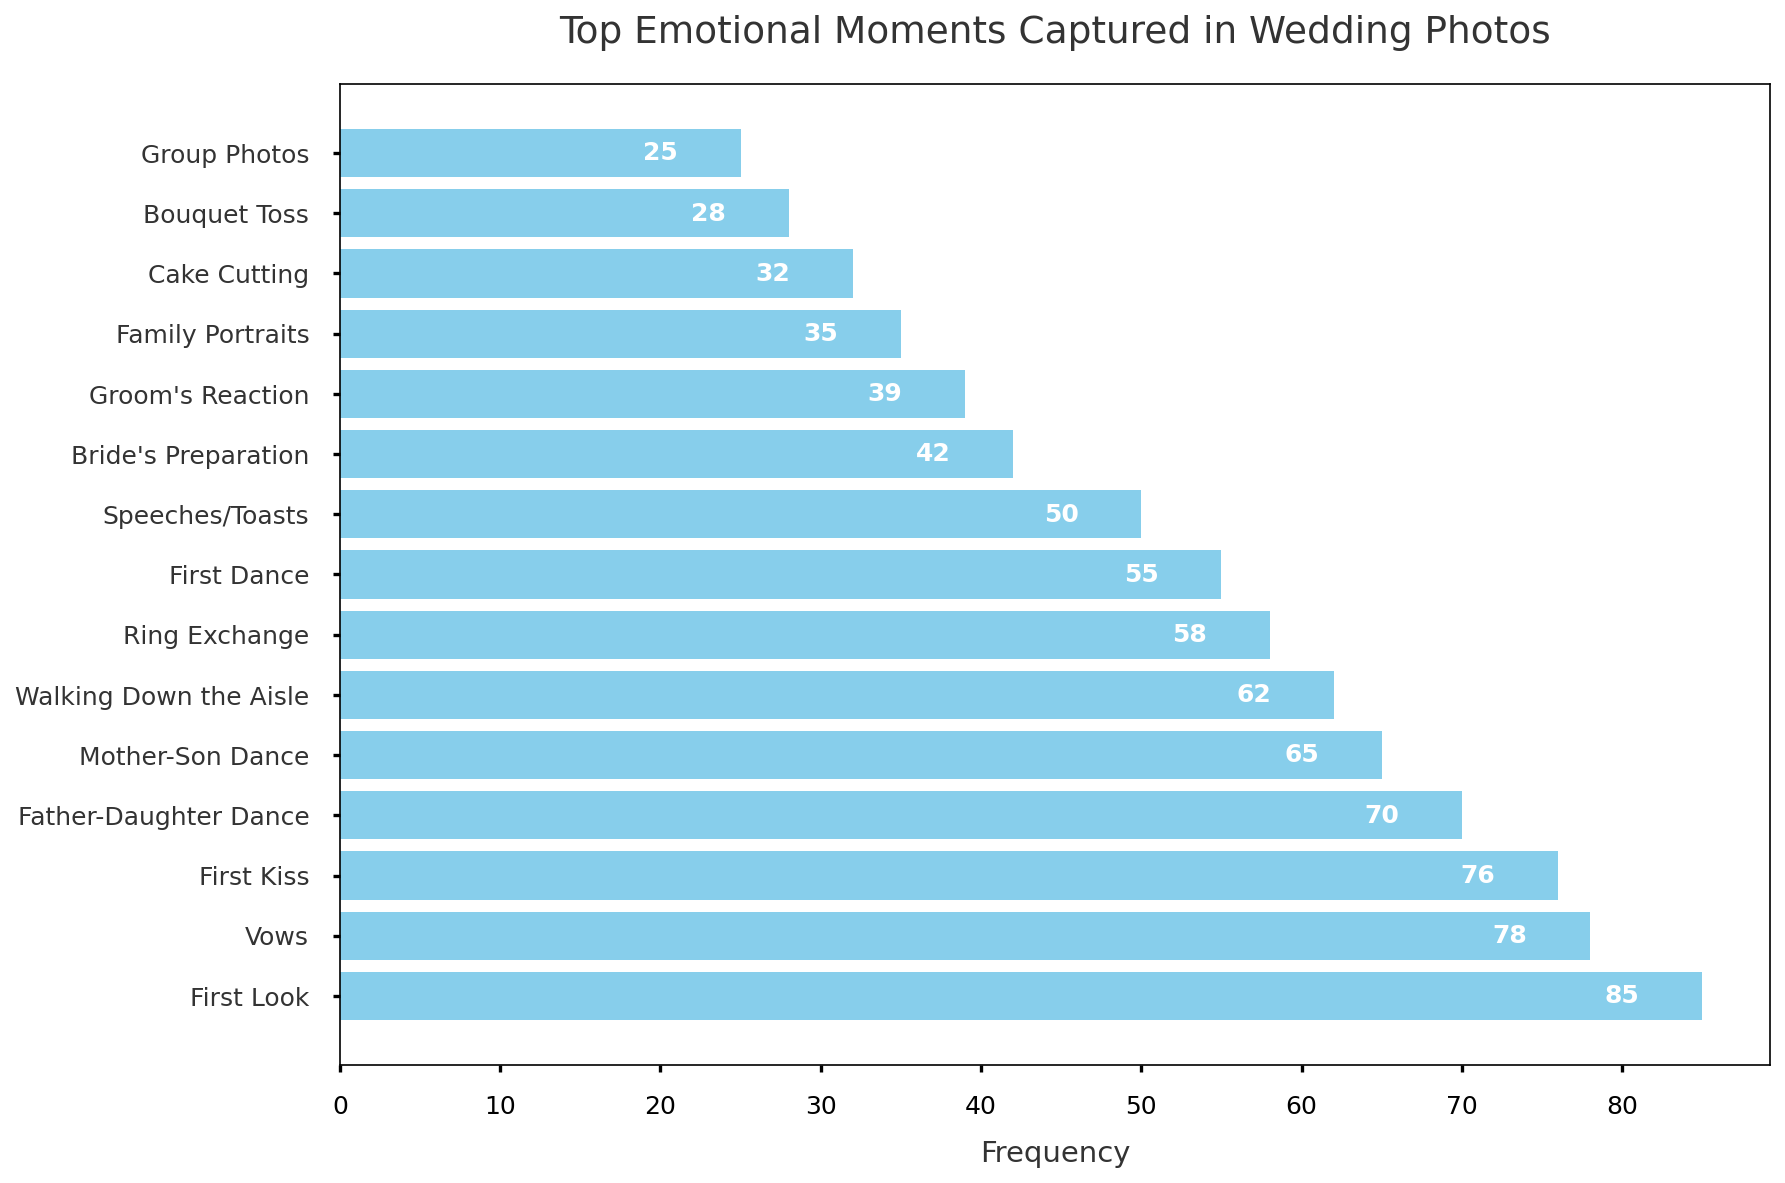What is the most frequently captured emotional moment in wedding photos? Identify the bar with the highest value (length). The "First Look" has the highest frequency of 85.
Answer: First Look How much more frequently is the "First Look" captured compared to the "Bouquet Toss"? Subtract the frequency of the "Bouquet Toss" from that of the "First Look": 85 - 28 = 57.
Answer: 57 Which emotional moment has a higher frequency, "Father-Daughter Dance" or "Mother-Son Dance"? Compare the lengths of the bars for "Father-Daughter Dance" and "Mother-Son Dance". The "Father-Daughter Dance" has a frequency of 70, while "Mother-Son Dance" has 65.
Answer: Father-Daughter Dance What is the total frequency of the top three most frequently captured emotional moments? Sum the frequencies of "First Look", "Vows", and "First Kiss": 85 + 78 + 76 = 239.
Answer: 239 How many moments have a frequency higher than 50? Count the bars with a frequency longer than 50 on the x-axis. There are 8 moments with a frequency above 50.
Answer: 8 Which moment is captured more often, "First Dance" or "Speeches/Toasts"? Compare the lengths of the bars for "First Dance" and "Speeches/Toasts". The "First Dance" has a frequency of 55, while "Speeches/Toasts" has 50.
Answer: First Dance What is the median frequency of all the captured moments? List the frequencies in ascending order and find the middle value. The frequencies are: 25, 28, 32, 35, 39, 42, 50, 55, 58, 62, 65, 70, 76, 78, 85. The median frequency is the 8th value, which is 55.
Answer: 55 How does the frequency of "Ring Exchange" compare to the frequency of "Bride's Preparation"? Compare the lengths of the bars for "Ring Exchange" and "Bride's Preparation". The "Ring Exchange" has a frequency of 58, while "Bride's Preparation" has 42.
Answer: Ring Exchange has a higher frequency Which captured moment has the lowest frequency, and what is it? Identify the bar with the shortest length. The "Group Photos" has the lowest frequency of 25.
Answer: Group Photos, 25 